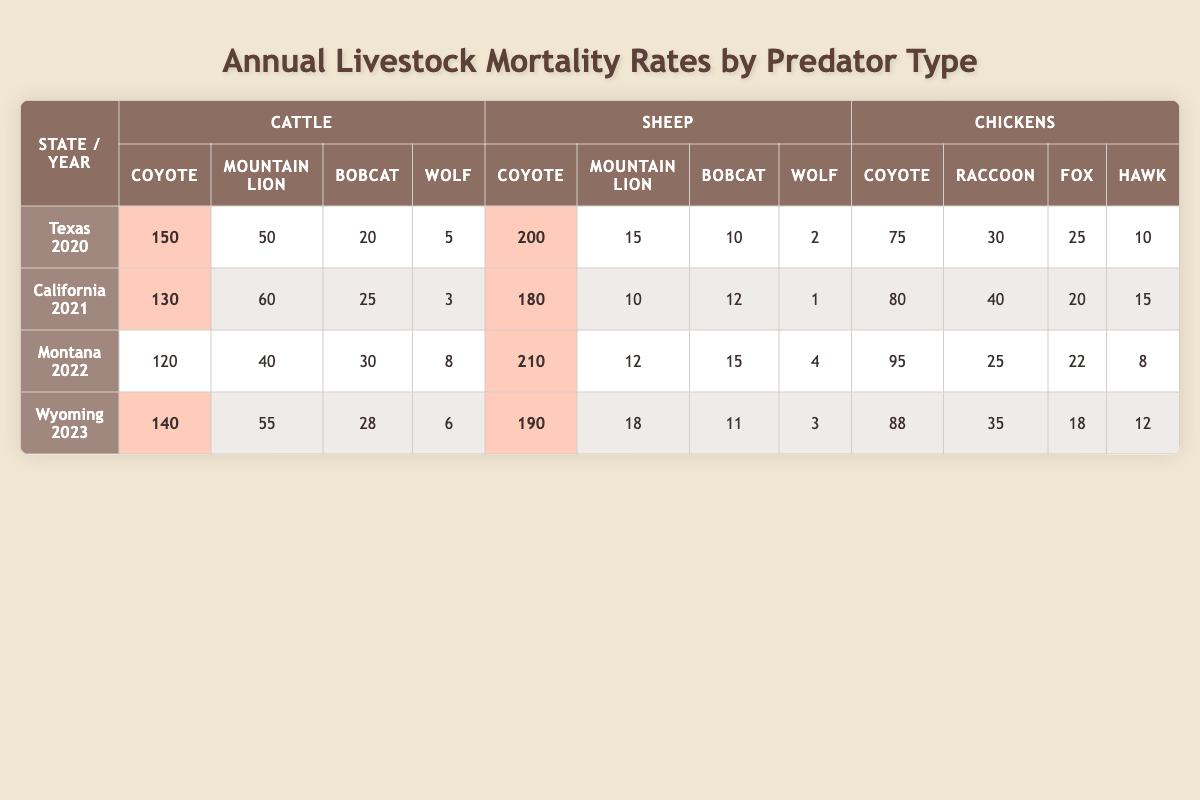What was the highest mortality rate for cattle due to coyotes? In the table, I will look at the cattle column for each state and year, focusing on the "Coyote" row. The values are 150 (Texas 2020), 130 (California 2021), 120 (Montana 2022), and 140 (Wyoming 2023). The highest value is 150 (Texas 2020).
Answer: 150 How many sheep were killed by wolves in Wyoming in 2023? We need to find the row for Wyoming in 2023 and then look at the "Wolf" column under the sheep section. The value listed there is 3.
Answer: 3 What is the total number of cattle killed by all predators in Texas in 2020? To find this, I will add the values under the cattle section for Texas 2020: 150 (Coyote) + 50 (Mountain Lion) + 20 (Bobcat) + 5 (Wolf) = 225.
Answer: 225 Which state had the highest mortality of chickens due to raccoons? I will check the "Raccoon" column under the chickens section for each state and year. The values are 30 (Texas 2020), 40 (California 2021), 25 (Montana 2022), and 35 (Wyoming 2023). The highest is 40 (California 2021).
Answer: California 2021 What is the average number of sheep killed by coyotes across all states and years? I will sum the coyote values for sheep across all years: 200 (Texas 2020) + 180 (California 2021) + 210 (Montana 2022) + 190 (Wyoming 2023) = 780. Then, I will divide by the number of states (4): 780 / 4 = 195.
Answer: 195 Is the number of cattle killed by mountain lions in Wyoming greater than in Montana in 2022? In the table, for Wyoming in 2023, the cattle killed by mountain lions is 55, while for Montana in 2022, it is 40. Since 55 is greater than 40, the answer is yes.
Answer: Yes How many more chickens were killed by hawks than by foxes in California in 2021? I will look at the values for "Hawk" and "Fox" under the chickens section for California 2021: 15 (Hawk) and 20 (Fox). To find the difference, I will subtract: 15 - 20 = -5. This means 20 more were killed by foxes.
Answer: 5 What is the total number of livestock (cattle, sheep, and chickens) killed by coyotes in 2022? I will look at the coyote value for each type of livestock in 2022 and add them: 120 (Cattle) + 210 (Sheep) + 95 (Chickens) = 425.
Answer: 425 Which year had the lowest total livestock mortality due to wolves? For total mortality due to wolves, I will add the values from the "Wolf" column across all states: 5 (Texas 2020) + 3 (California 2021) + 4 (Montana 2022) + 6 (Wyoming 2023) = 18. The year with the lowest value from this addition is California 2021, which had 3.
Answer: California 2021 What percentage of sheep killed in Montana in 2022 were killed by coyotes? There were 210 sheep killed by coyotes, and the total number of sheep deaths in Montana 2022 was 210 + 12 + 15 + 4 = 241. To find the percentage, I will calculate: (210 / 241) * 100 ≈ 87.12%.
Answer: 87.12% 